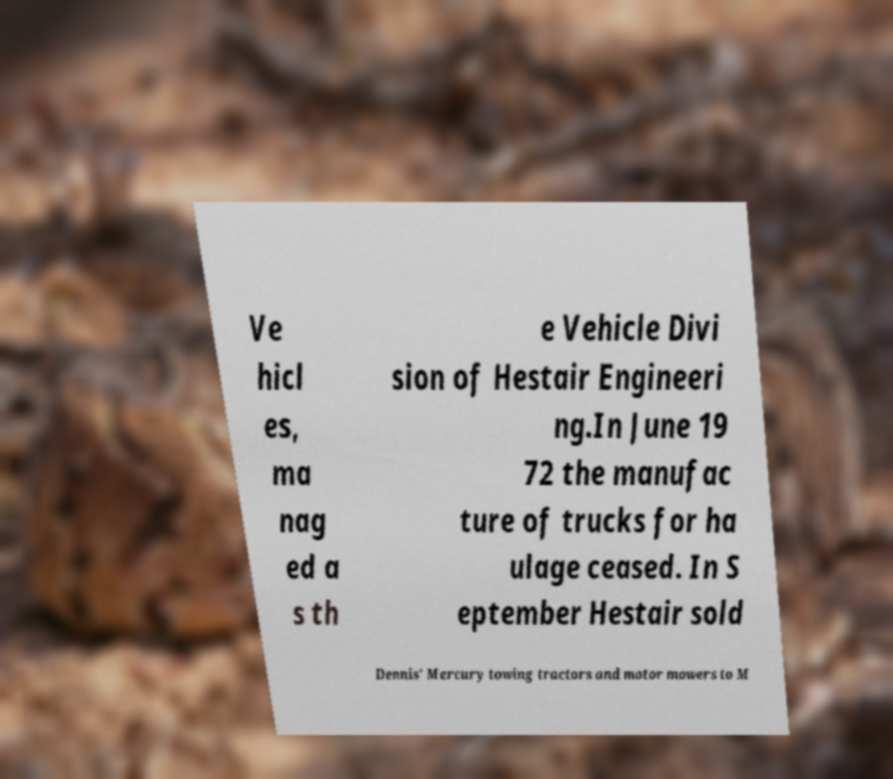Please read and relay the text visible in this image. What does it say? Ve hicl es, ma nag ed a s th e Vehicle Divi sion of Hestair Engineeri ng.In June 19 72 the manufac ture of trucks for ha ulage ceased. In S eptember Hestair sold Dennis' Mercury towing tractors and motor mowers to M 